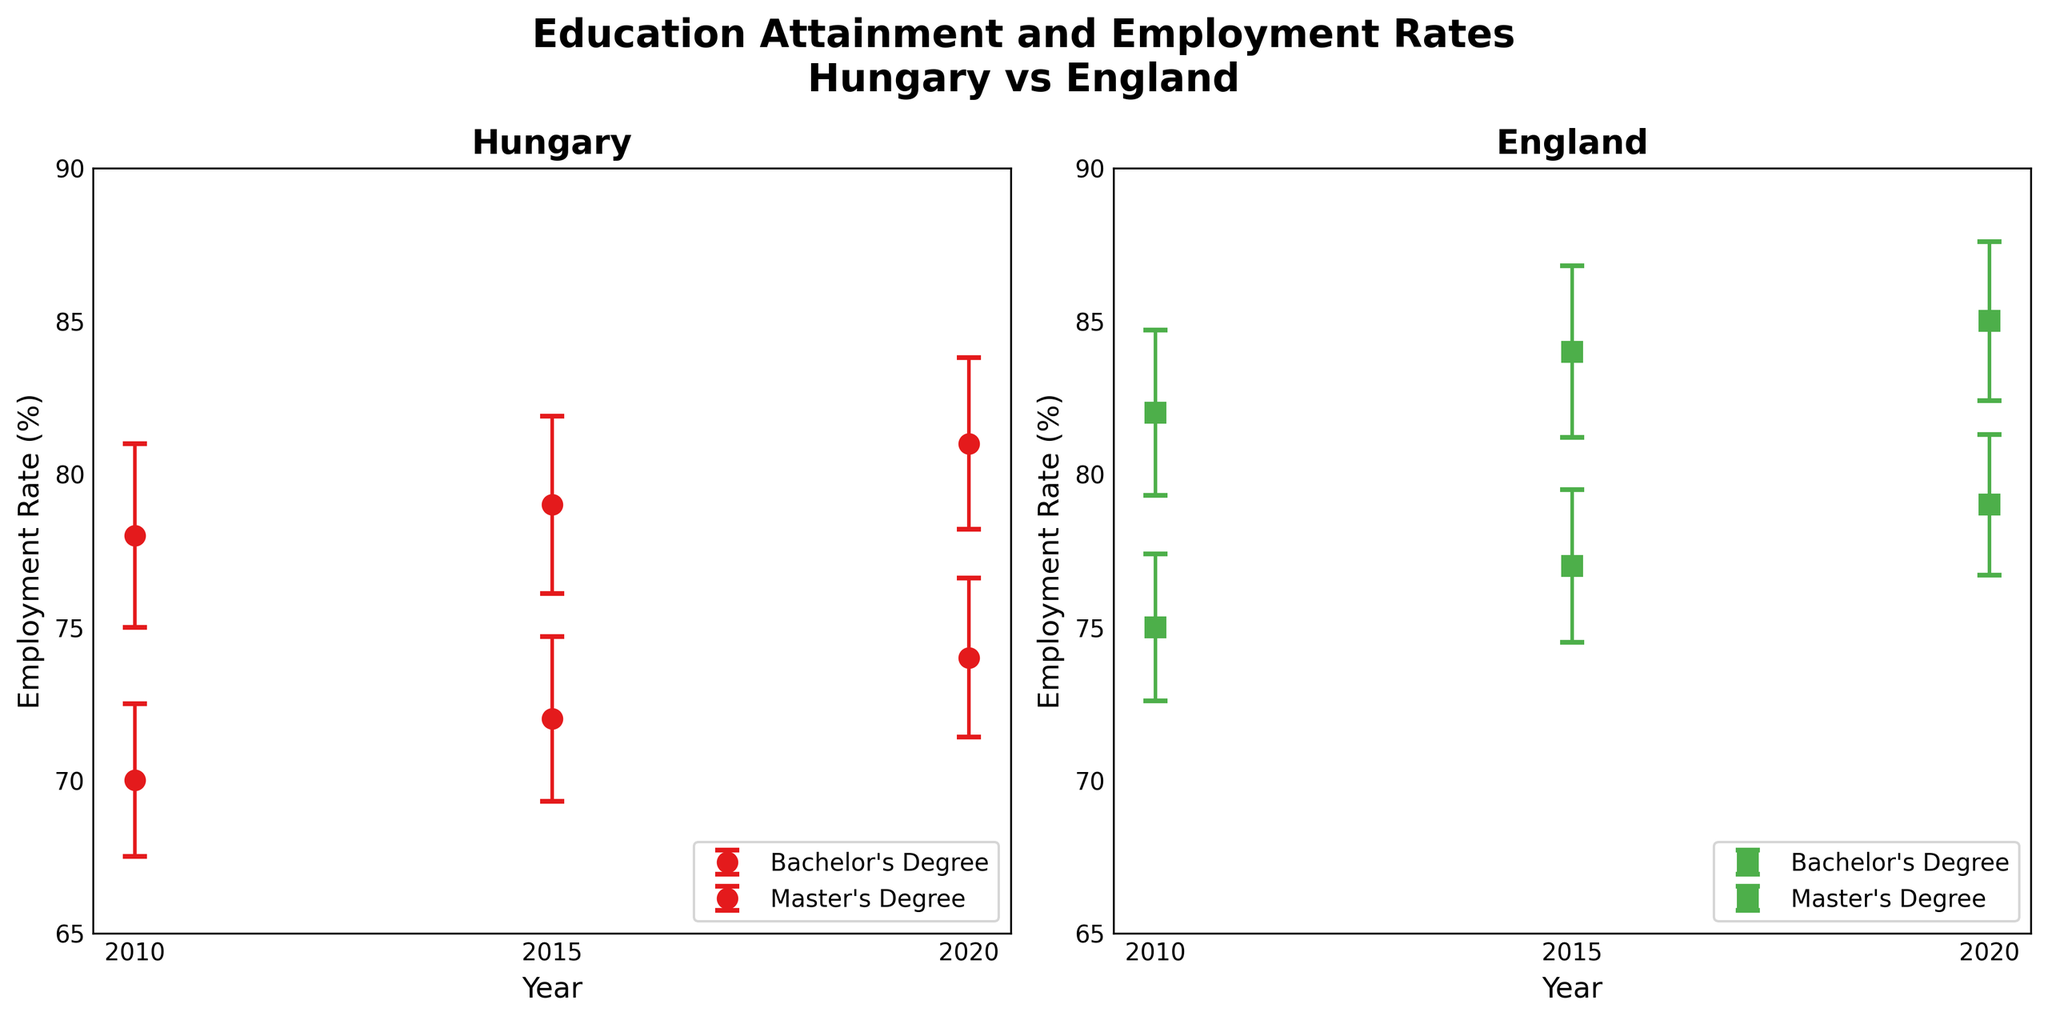What's the title of the figure? The title is located at the top center of the figure and reads "Education Attainment and Employment Rates Hungary vs England".
Answer: Education Attainment and Employment Rates Hungary vs England How many years are represented in the data? The x-axis shows the years, which are 2010, 2015, and 2020.
Answer: 3 Which country has the higher employment rate for Master's Degree holders in 2020? By comparing the points for 2020 on both subplots, England has the higher employment rate for Master's Degree holders.
Answer: England What's the employment rate for Bachelor's Degree holders in Hungary in 2015, including its error? In the Hungary subplot, the point for Bachelor's Degree in 2015 is marked at the employment rate of 72% with an error bar of ±2.7%.
Answer: 72% ± 2.7% Is the employment rate for Bachelor's Degree holders in England higher than that in Hungary in 2010? By looking at the 2010 points for Bachelor's Degree on both subplots, England's rate is 75%, while Hungary's rate is 70%. Hence, England's is higher.
Answer: Yes What's the difference in employment rates for Master's Degree holders between Hungary and England in 2015? The employment rate for Master's Degree holders in England is 84%, while in Hungary, it is 79%. The difference is 84% - 79% = 5%.
Answer: 5% Did the employment rate for Bachelor's Degree holders in Hungary increase or decrease between 2010 and 2020? In Hungary's subplot, the employment rate for Bachelor's Degree holders increased from 70% in 2010 to 74% in 2020.
Answer: Increase What’s the average employment rate for Master's Degree holders in England across all years? The employment rates for Master's Degree holders in England are 82% (2010), 84% (2015), and 85% (2020). The average is (82 + 84 + 85)/3 = 83.67%.
Answer: 83.67% Which education level had a smaller range of employment rate changes in Hungary from 2010 to 2020? For Bachelor's Degree, the range is 74% - 70% = 4%. For Master's Degree, the range is 81% - 78% = 3%. Therefore, Master's Degree had a smaller range.
Answer: Master's Degree In which year did England have the smallest error margin for Bachelor's Degree employment rates? On the England subplot, the smallest error margin for Bachelor's Degree (error bars) is in 2020, with an error of ±2.3%.
Answer: 2020 